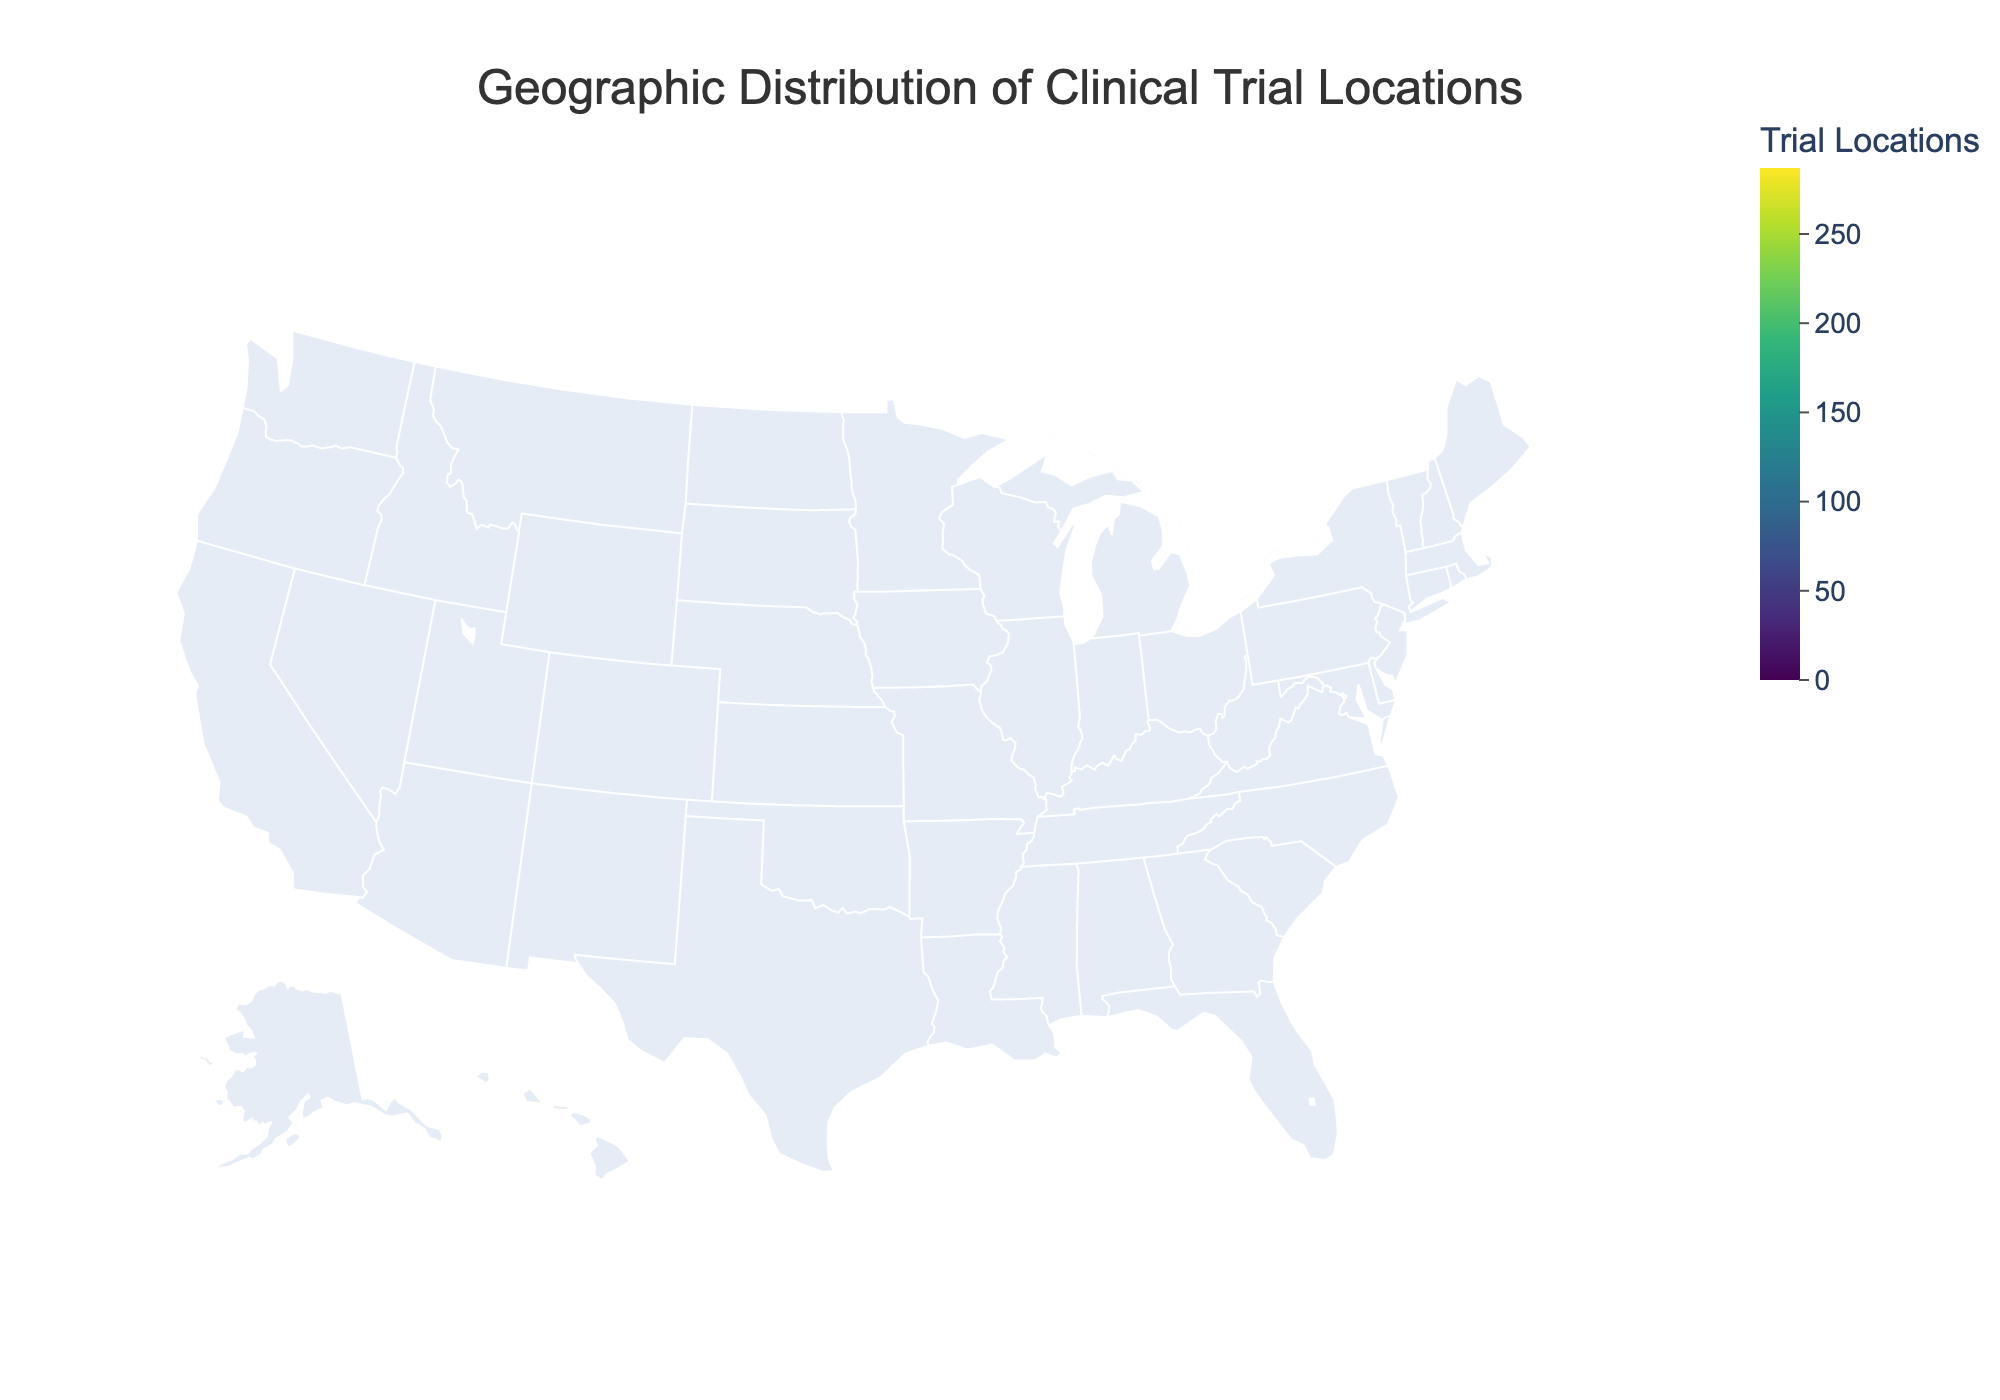What's the title of the figure? The title of the figure is usually found at the top, centered in bold text, making it easy to identify. Here, it clearly states, "Geographic Distribution of Clinical Trial Locations."
Answer: Geographic Distribution of Clinical Trial Locations Which state has the highest number of clinical trial locations? The state with the darkest color on the map indicates the highest number. California is the darkest, indicating the highest number of locations.
Answer: California How many clinical trial locations does Texas have compared to New York? To determine this, observe the numbers next to Texas and New York. Texas has 178 locations, and New York has 203. The difference is 203 - 178.
Answer: 25 Which states have exactly 82 clinical trial locations? By reviewing the color and numerical labels on the map, Maryland shows exactly 82 clinical trial locations.
Answer: Maryland What is the average number of clinical trial locations across the states listed? Sum all the trial locations: 287 + 203 + 178 + 156 + ... + 28 = 2210. Then, divide by the number of states listed (24). 2210 / 24.
Answer: 92.08 Which state has the least number of clinical trial locations? The state with the lightest color on the map typically represents the least number of clinical trial locations. Alabama is the lightest, with 28 locations.
Answer: Alabama Are there any states that have between 40 and 50 clinical trial locations? Examining the ranges and colors, Colorado and Arizona fall in this bracket with 48 and 45 locations, respectively.
Answer: Colorado and Arizona How do the clinical trial locations in Illinois compare to Massachusetts? Illinois has 115 clinical trial locations, whereas Massachusetts has 142. By comparing the numerical values, Massachusetts has more.
Answer: Massachusetts If you combine the clinical trial locations in Florida and Pennsylvania, how many locations would you have in total? Adding the numbers for Florida (156) and Pennsylvania (129) results in 156 + 129.
Answer: 285 